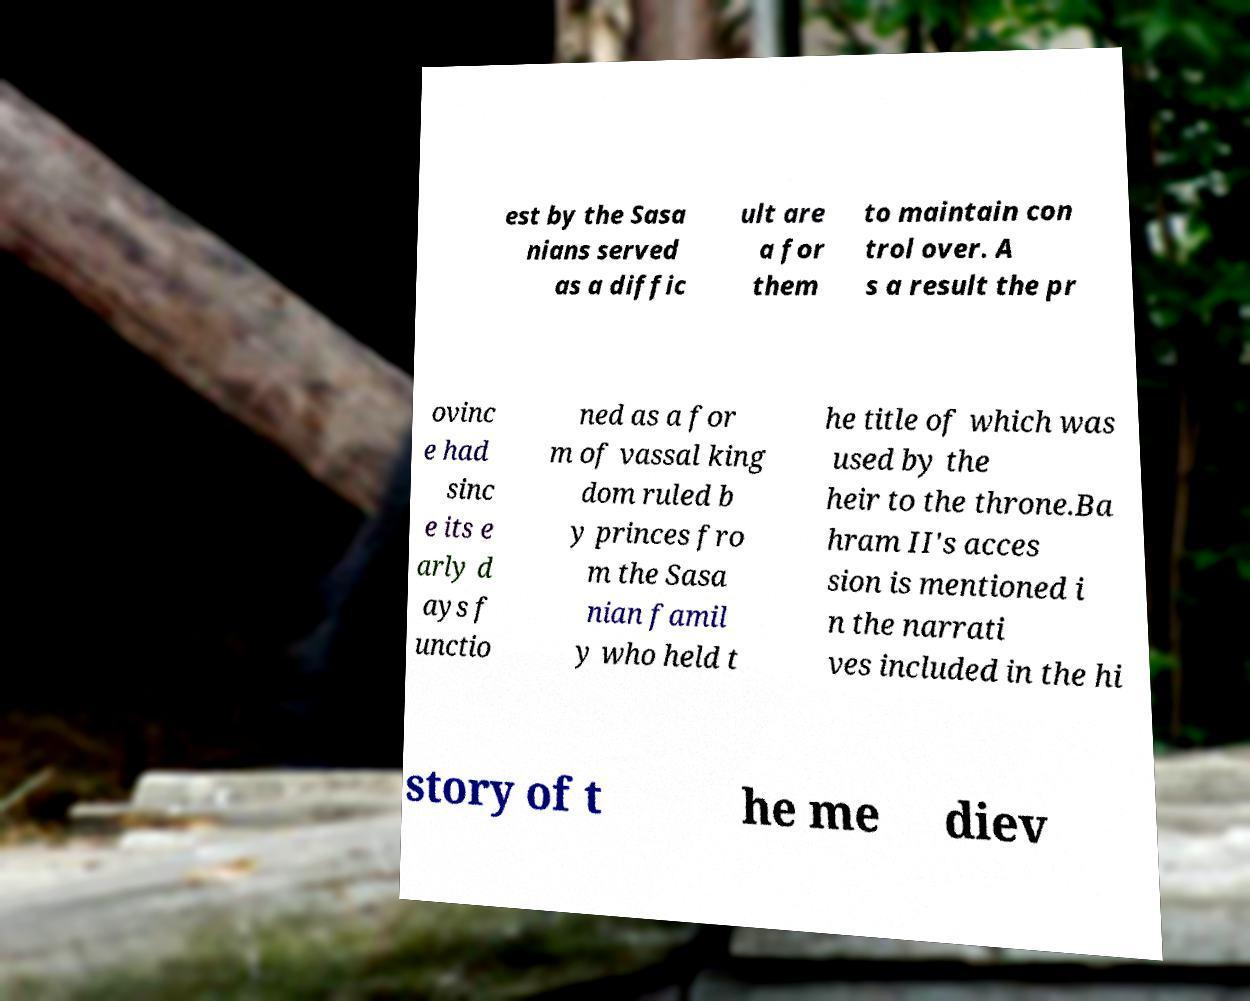For documentation purposes, I need the text within this image transcribed. Could you provide that? est by the Sasa nians served as a diffic ult are a for them to maintain con trol over. A s a result the pr ovinc e had sinc e its e arly d ays f unctio ned as a for m of vassal king dom ruled b y princes fro m the Sasa nian famil y who held t he title of which was used by the heir to the throne.Ba hram II's acces sion is mentioned i n the narrati ves included in the hi story of t he me diev 